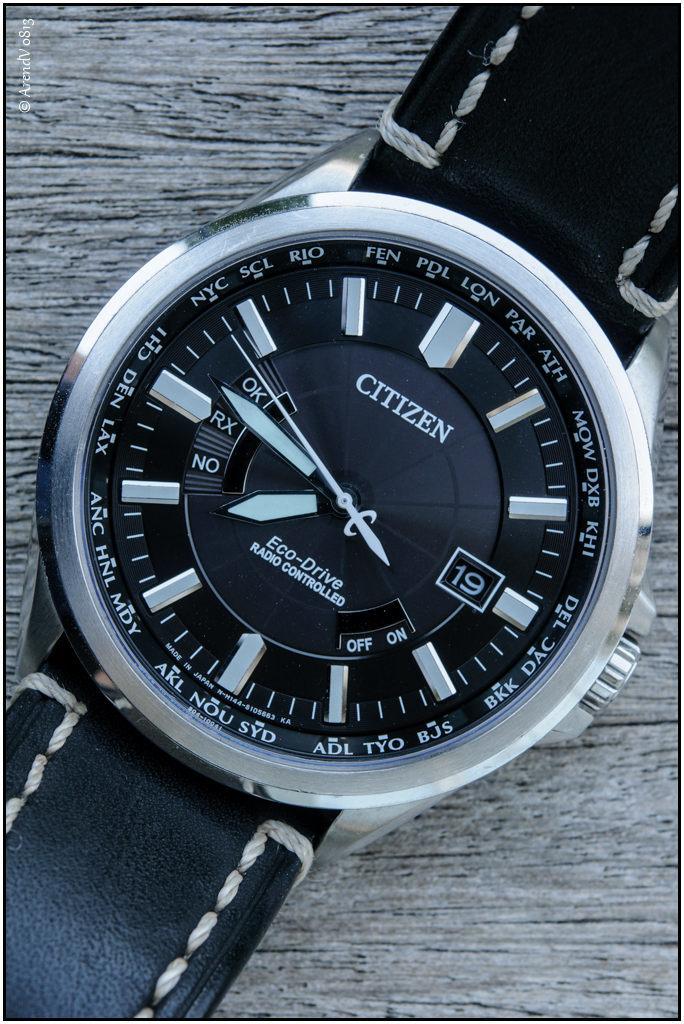What kind of module is at the front?
Provide a succinct answer. Citizen. What is the brand of this watch?
Your response must be concise. Citizen. 